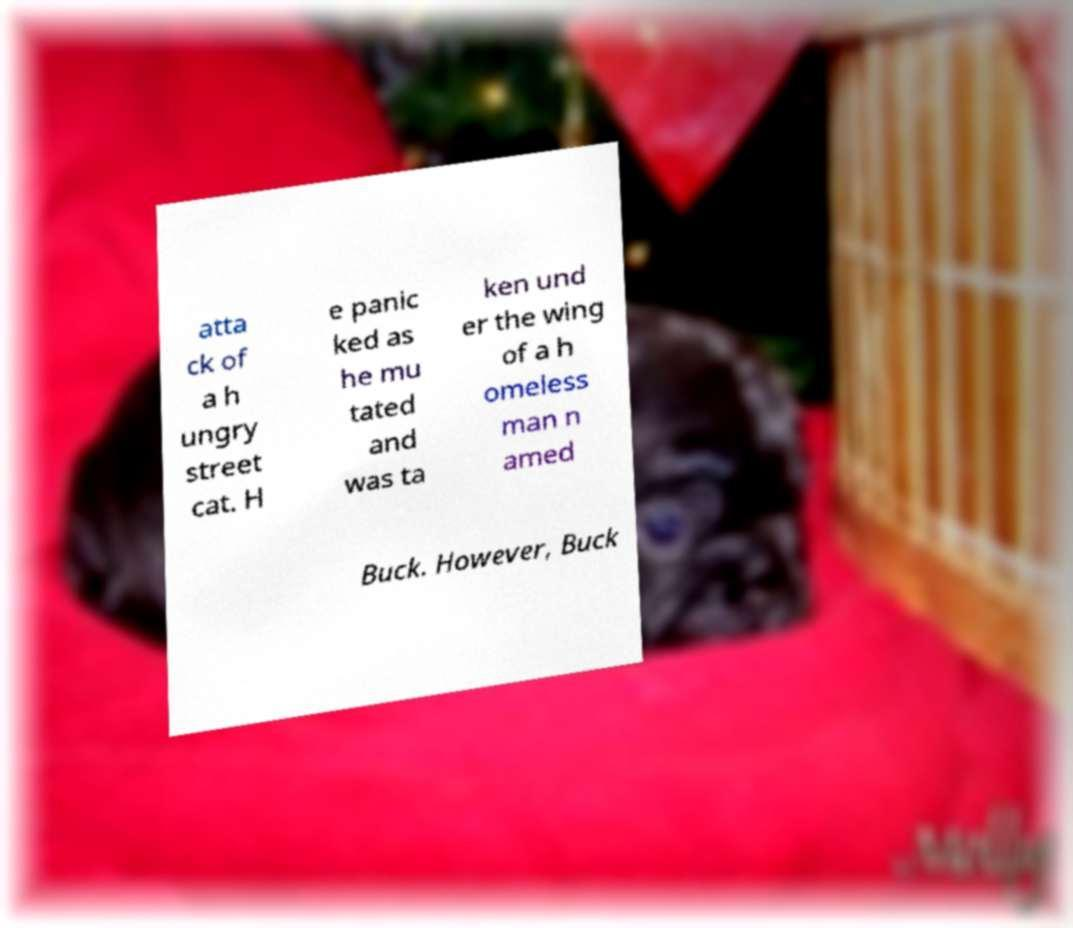What messages or text are displayed in this image? I need them in a readable, typed format. atta ck of a h ungry street cat. H e panic ked as he mu tated and was ta ken und er the wing of a h omeless man n amed Buck. However, Buck 